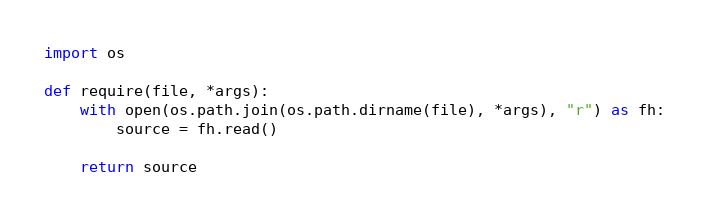Convert code to text. <code><loc_0><loc_0><loc_500><loc_500><_Python_>import os

def require(file, *args):
    with open(os.path.join(os.path.dirname(file), *args), "r") as fh:
        source = fh.read()
    
    return source
</code> 